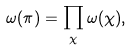Convert formula to latex. <formula><loc_0><loc_0><loc_500><loc_500>\omega ( \pi ) = \prod _ { \chi } \omega ( \chi ) ,</formula> 